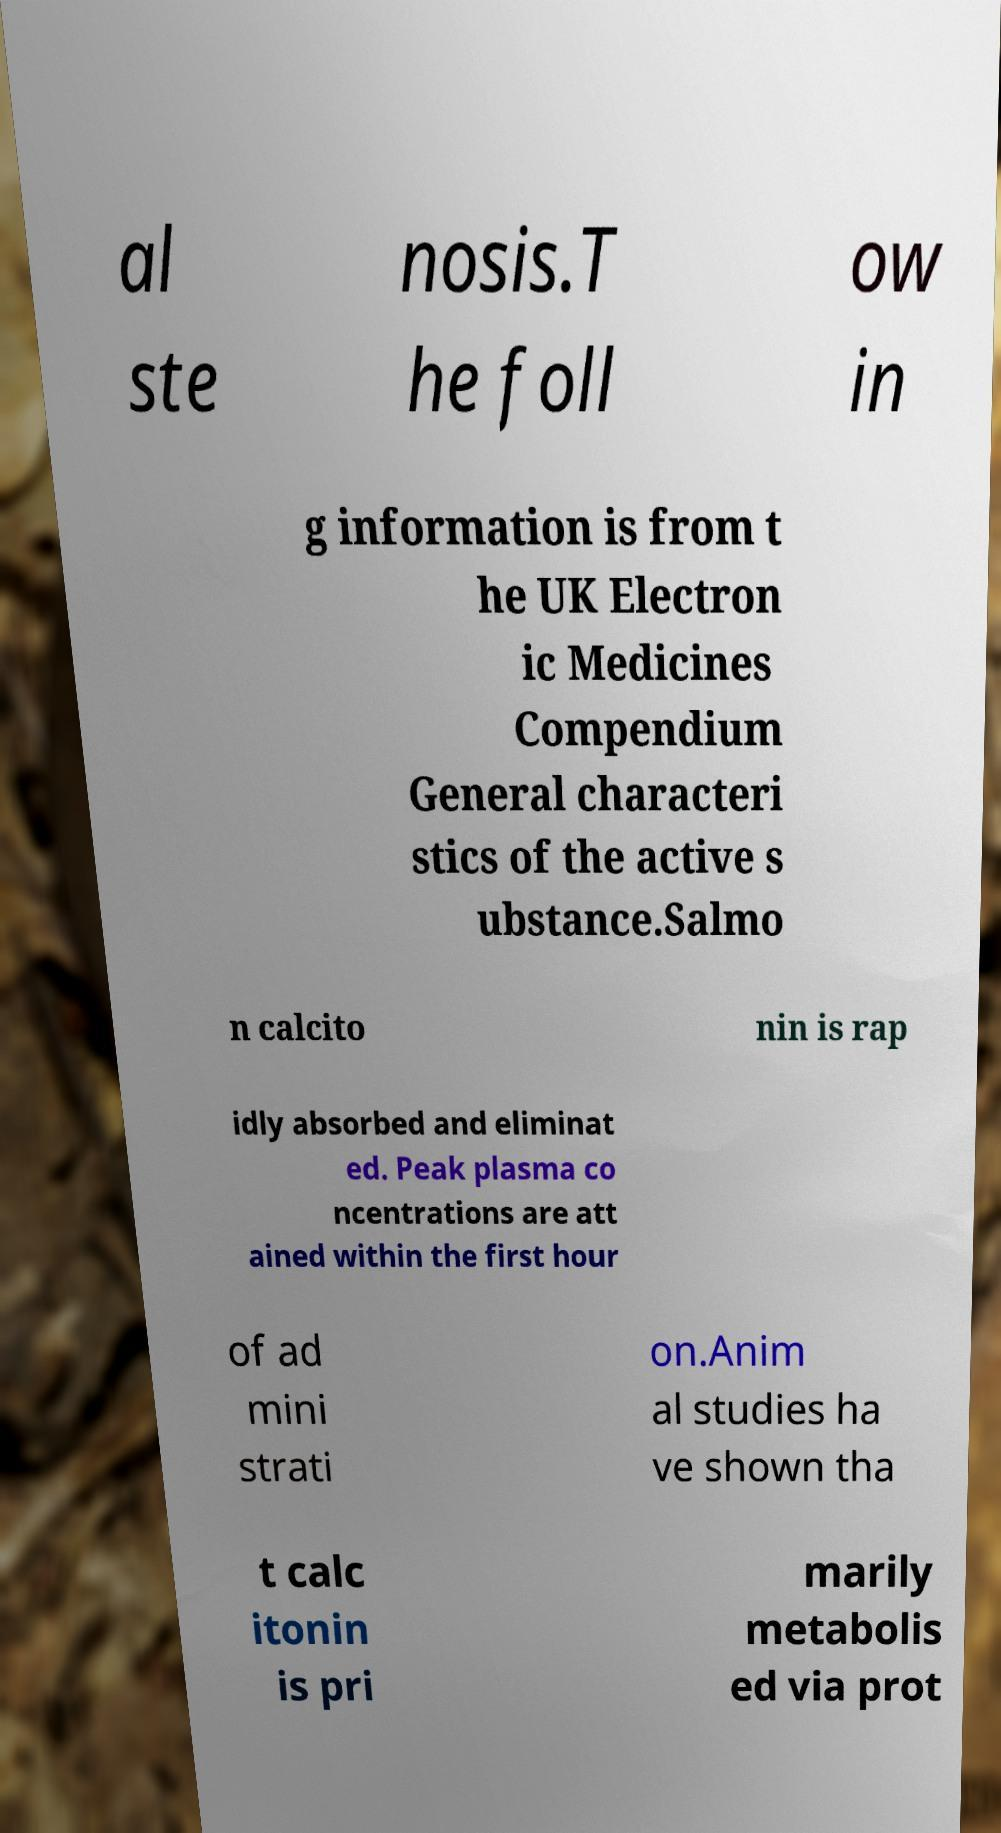Could you extract and type out the text from this image? al ste nosis.T he foll ow in g information is from t he UK Electron ic Medicines Compendium General characteri stics of the active s ubstance.Salmo n calcito nin is rap idly absorbed and eliminat ed. Peak plasma co ncentrations are att ained within the first hour of ad mini strati on.Anim al studies ha ve shown tha t calc itonin is pri marily metabolis ed via prot 